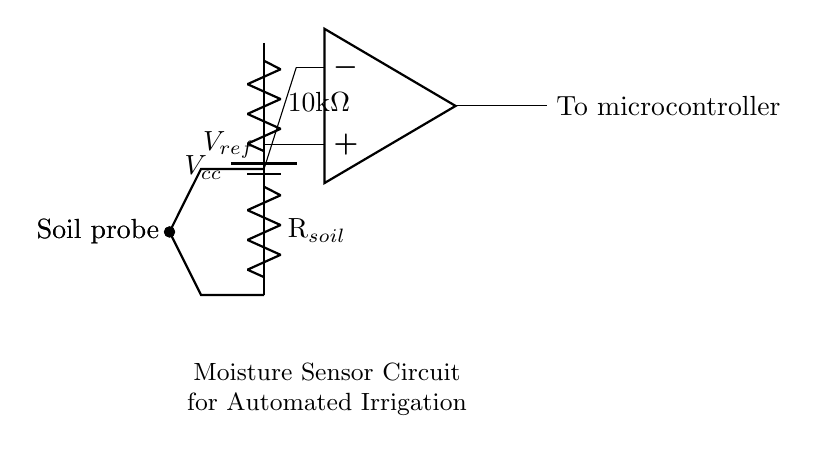What is the reference voltage in this circuit? The reference voltage is indicated by the label Vref connected to the non-inverting input of the op-amp, which is typically set at a specific value to compare against the sensor reading. The diagram does not provide a specific number, but it is essential for the op-amp's operation.
Answer: Vref What is the resistor value of the upper resistor in the voltage divider? The upper resistor in the voltage divider is explicitly labeled as 10k ohms, which can be seen from the label next to the resistor component in the circuit diagram.
Answer: 10k ohms What type of component is used to measure soil moisture? The circuit includes two soil probes connected in a configuration that allows the measurement of the electrical resistance of the soil, which is indicative of moisture levels. The probes are specifically labeled as soil probes in the diagram.
Answer: Soil probes What is the output of the op-amp connected to? The output of the op-amp is connected to a microcontroller, which is indicated by the label "To microcontroller" in the circuit. This connection signifies that the op-amp's output is to be processed by the microcontroller for further actions in the automated irrigation system.
Answer: Microcontroller Why is a voltage divider used in this circuit? The voltage divider is utilized to scale down the voltage from the soil probes, allowing for a more manageable voltage level that can be safely read by the op-amp's input. The division of voltage occurs due to the ratio of the resistance values in the divider, leading to a proportional output based on soil moisture levels.
Answer: To scale voltage What is the purpose of the op-amp in this moisture sensor circuit? The op-amp serves as a comparator that compares the voltage from the soil probes against the reference voltage. By amplifying or buffering the difference between these voltages, the op-amp can trigger the microcontroller to activate irrigation based on the moisture content detected in the soil.
Answer: Comparator What happens when the soil is dry in this circuit? When the soil is dry, the resistance across the soil probes increases, which leads to a higher voltage at the op-amp inputs compared to the reference voltage. Consequently, the op-amp output will change, signaling the microcontroller to activate the irrigation system to provide water to the dry soil.
Answer: Activates irrigation 